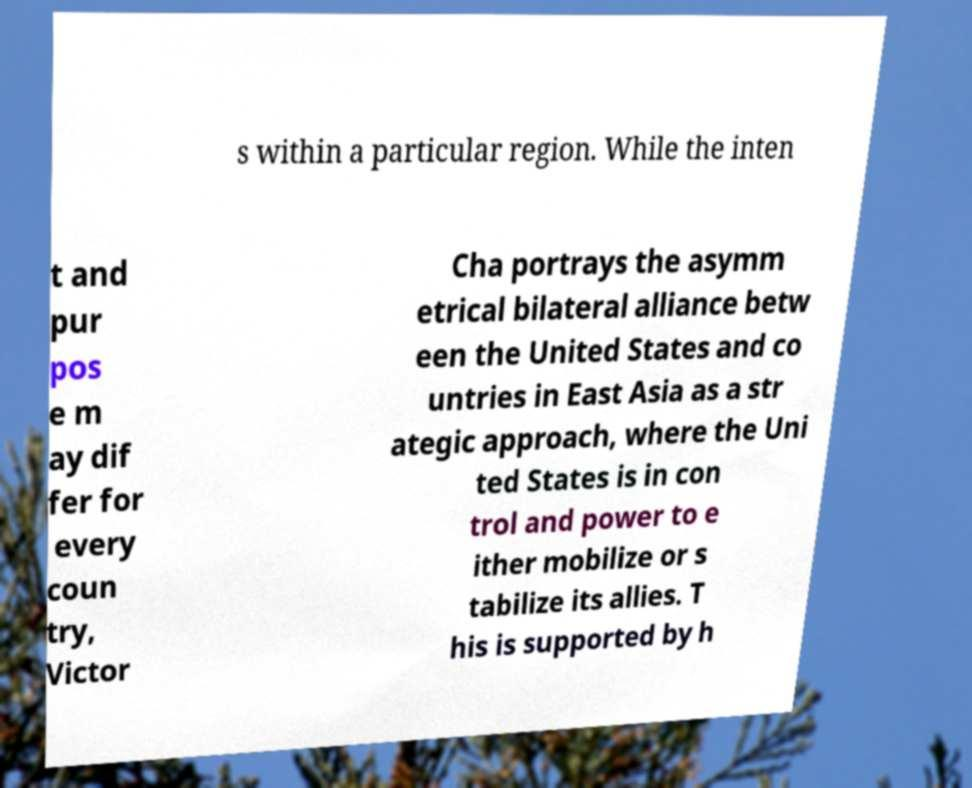Please identify and transcribe the text found in this image. s within a particular region. While the inten t and pur pos e m ay dif fer for every coun try, Victor Cha portrays the asymm etrical bilateral alliance betw een the United States and co untries in East Asia as a str ategic approach, where the Uni ted States is in con trol and power to e ither mobilize or s tabilize its allies. T his is supported by h 